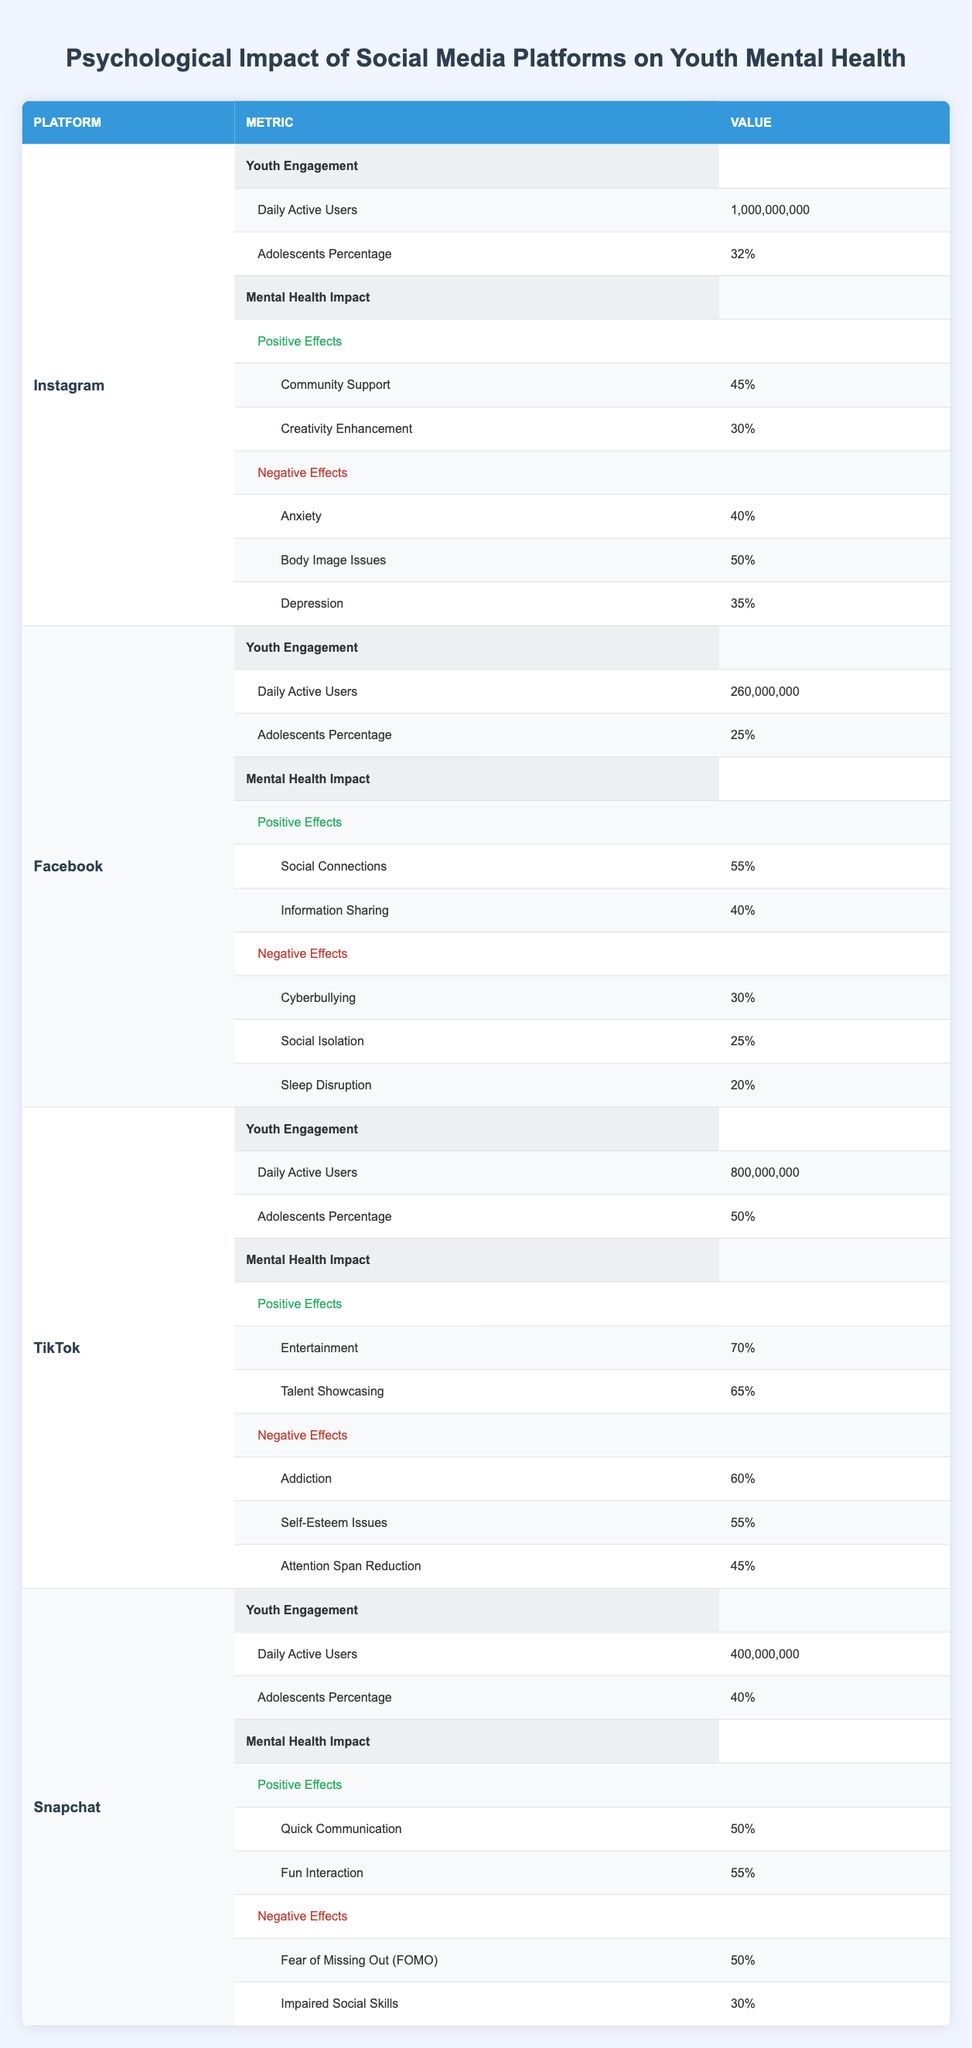What is the percentage of adolescents using TikTok? The table shows that the Adolescents Percentage for TikTok is 50%.
Answer: 50% Which platform has the highest percentage of positive effects in terms of entertainment? TikTok has a positive effect percentage of 70% for Entertainment, which is the highest among all platforms listed.
Answer: TikTok True or False: Instagram has a higher percentage of daily active users than Snapchat. The table states Instagram has 1,000,000,000 daily active users while Snapchat has 400,000,000. Therefore, the statement is true.
Answer: True What are the total negative effects percentages for Facebook? Facebook has three negative effects: Cyberbullying (30%), Social Isolation (25%), and Sleep Disruption (20%). Summing these gives 30 + 25 + 20 = 75%.
Answer: 75% Which social media platform reports the least amount of anxiety-related negative effects among adolescents? The table indicates that Instagram reports 40% anxiety, Facebook reports 30%, TikTok has no specific anxiety number listed, and Snapchat does not mention anxiety. Since TikTok does not list it, it can be inferred as the least.
Answer: TikTok How does the percentage of Community Support on Instagram compare to Social Connections on Facebook? Instagram reports Community Support at 45% and Facebook reports Social Connections at 55%. Therefore, Social Connections is higher than Community Support.
Answer: Social Connections is higher What is the average percentage of positive effects across all platforms? The positive effects percentages for the platforms are: Instagram 45 + 30 = 75%, Facebook 55 + 40 = 95%, TikTok 70 + 65 = 135%, Snapchat 50 + 55 = 105%. The total is 75 + 95 + 135 + 105 = 410%. Dividing this by the number of platforms (4) gives an average of 410/4 = 102.5%.
Answer: 102.5% Which platform has the highest reported negative effects related to body image issues? Instagram reports Body Image Issues as 50%, which is the highest figure for negative effects listed in the table.
Answer: Instagram What is the difference in the percentage of daily active users between Facebook and TikTok? Facebook has 260,000,000 daily active users while TikTok has 800,000,000. The difference is 800,000,000 - 260,000,000 = 540,000,000.
Answer: 540,000,000 